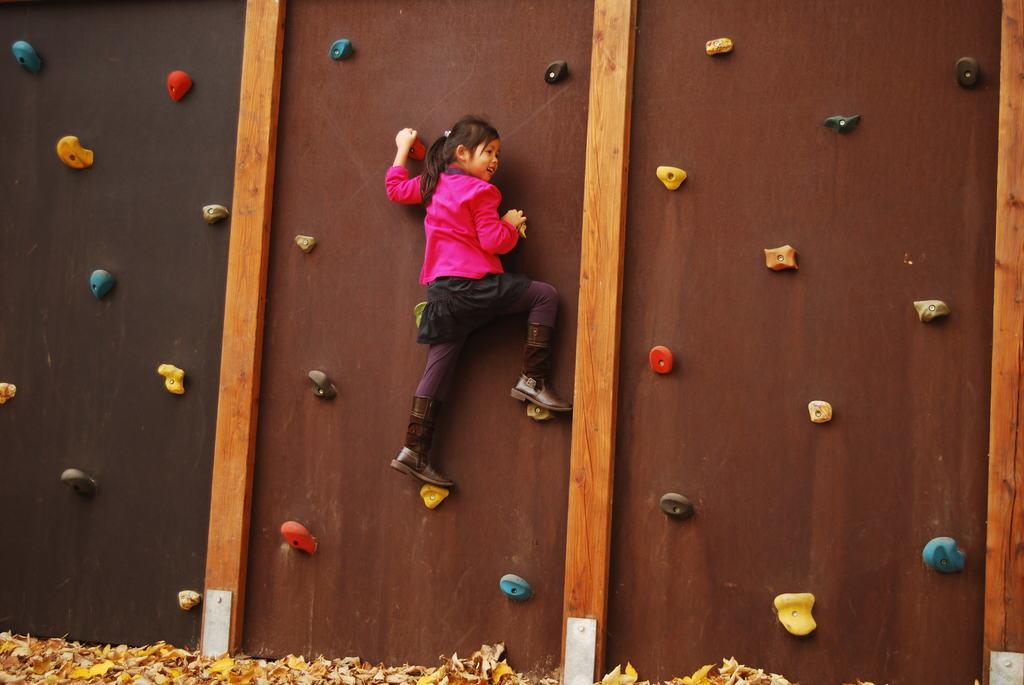Describe this image in one or two sentences. In this image we can see there is a girl climbing the wall. At the bottom of the image there are some dry leaves. 